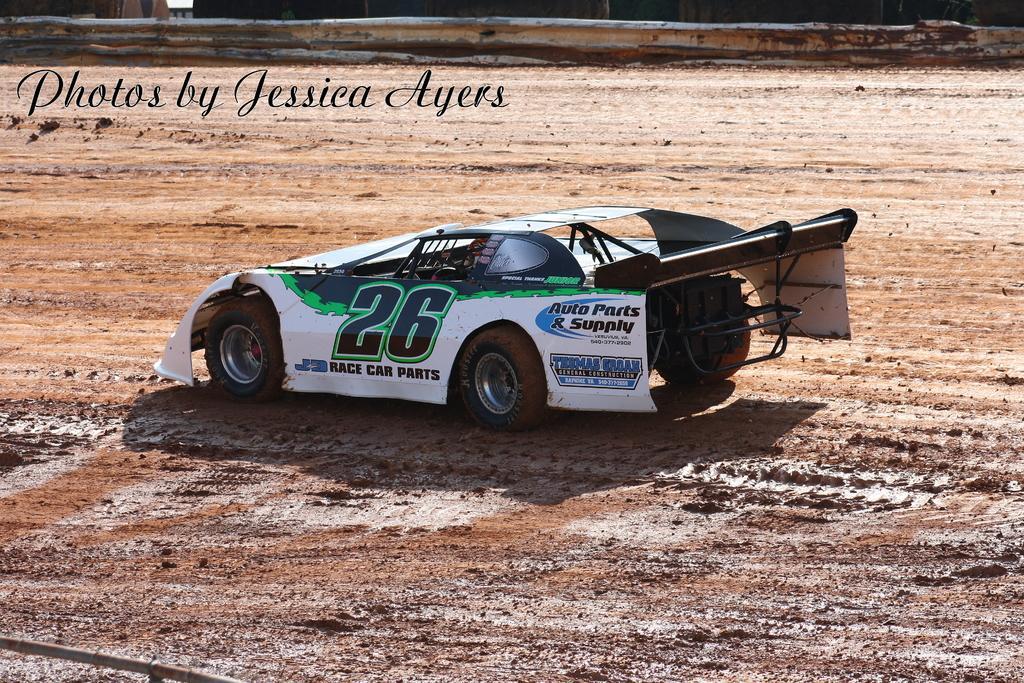Please provide a concise description of this image. In the center of the picture there is a car. In this picture there is mud. At the top there is railing and text. 